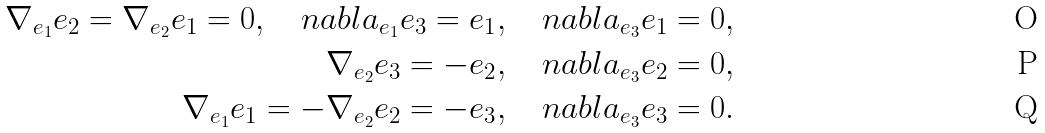<formula> <loc_0><loc_0><loc_500><loc_500>\nabla _ { e _ { 1 } } e _ { 2 } = \nabla _ { e _ { 2 } } e _ { 1 } = 0 , \quad n a b l a _ { e _ { 1 } } e _ { 3 } = e _ { 1 } , \quad n a b l a _ { e _ { 3 } } e _ { 1 } = 0 , \\ \nabla _ { e _ { 2 } } e _ { 3 } = - e _ { 2 } , \quad n a b l a _ { e _ { 3 } } e _ { 2 } = 0 , \\ \nabla _ { e _ { 1 } } e _ { 1 } = - \nabla _ { e _ { 2 } } e _ { 2 } = - e _ { 3 } , \quad n a b l a _ { e _ { 3 } } e _ { 3 } = 0 .</formula> 